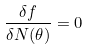<formula> <loc_0><loc_0><loc_500><loc_500>\frac { \delta f } { \delta N ( \theta ) } = 0</formula> 